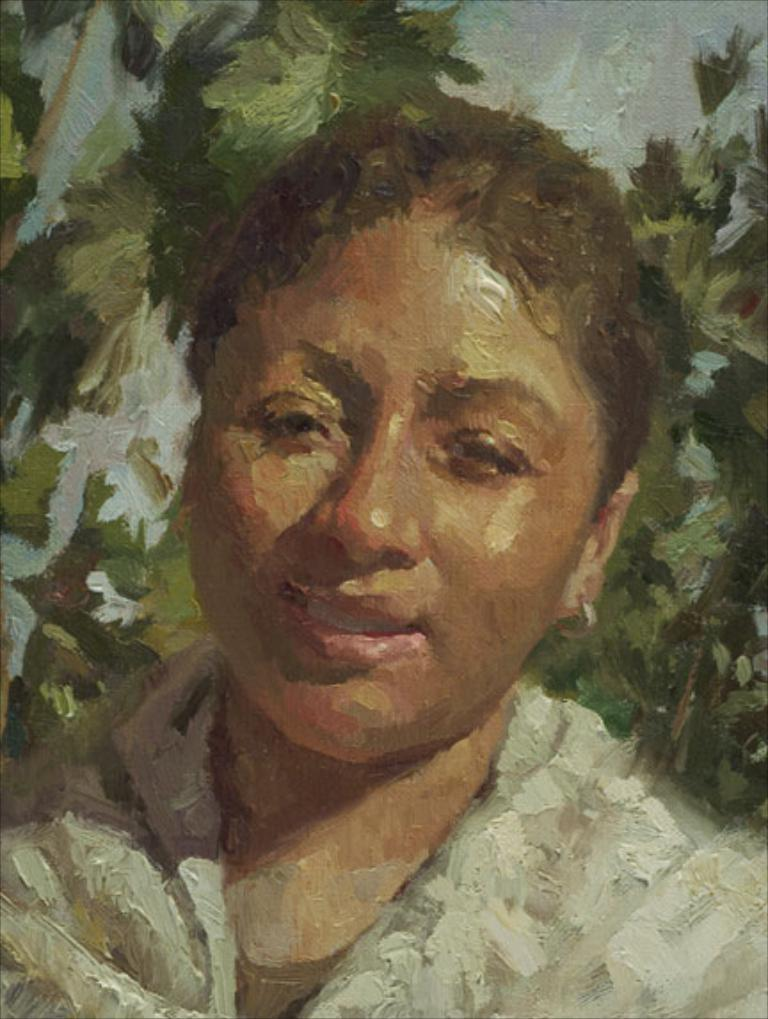What is the main subject of the image? The image contains an art piece. What does the art piece depict? The art piece depicts a girl. What type of meat is being served to the men in the image? There are no men or meat present in the image; it only contains an art piece depicting a girl. 